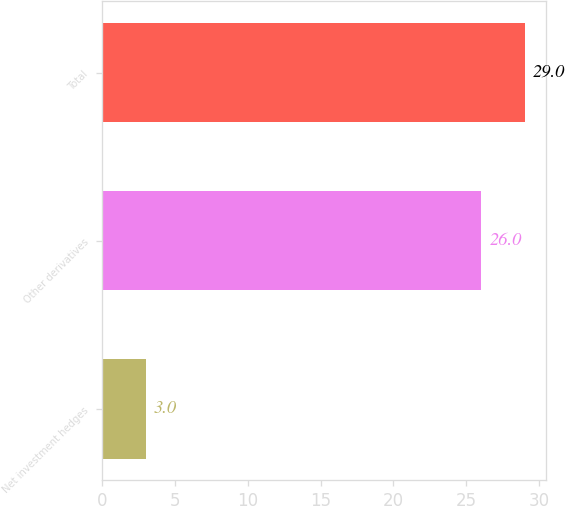Convert chart. <chart><loc_0><loc_0><loc_500><loc_500><bar_chart><fcel>Net investment hedges<fcel>Other derivatives<fcel>Total<nl><fcel>3<fcel>26<fcel>29<nl></chart> 